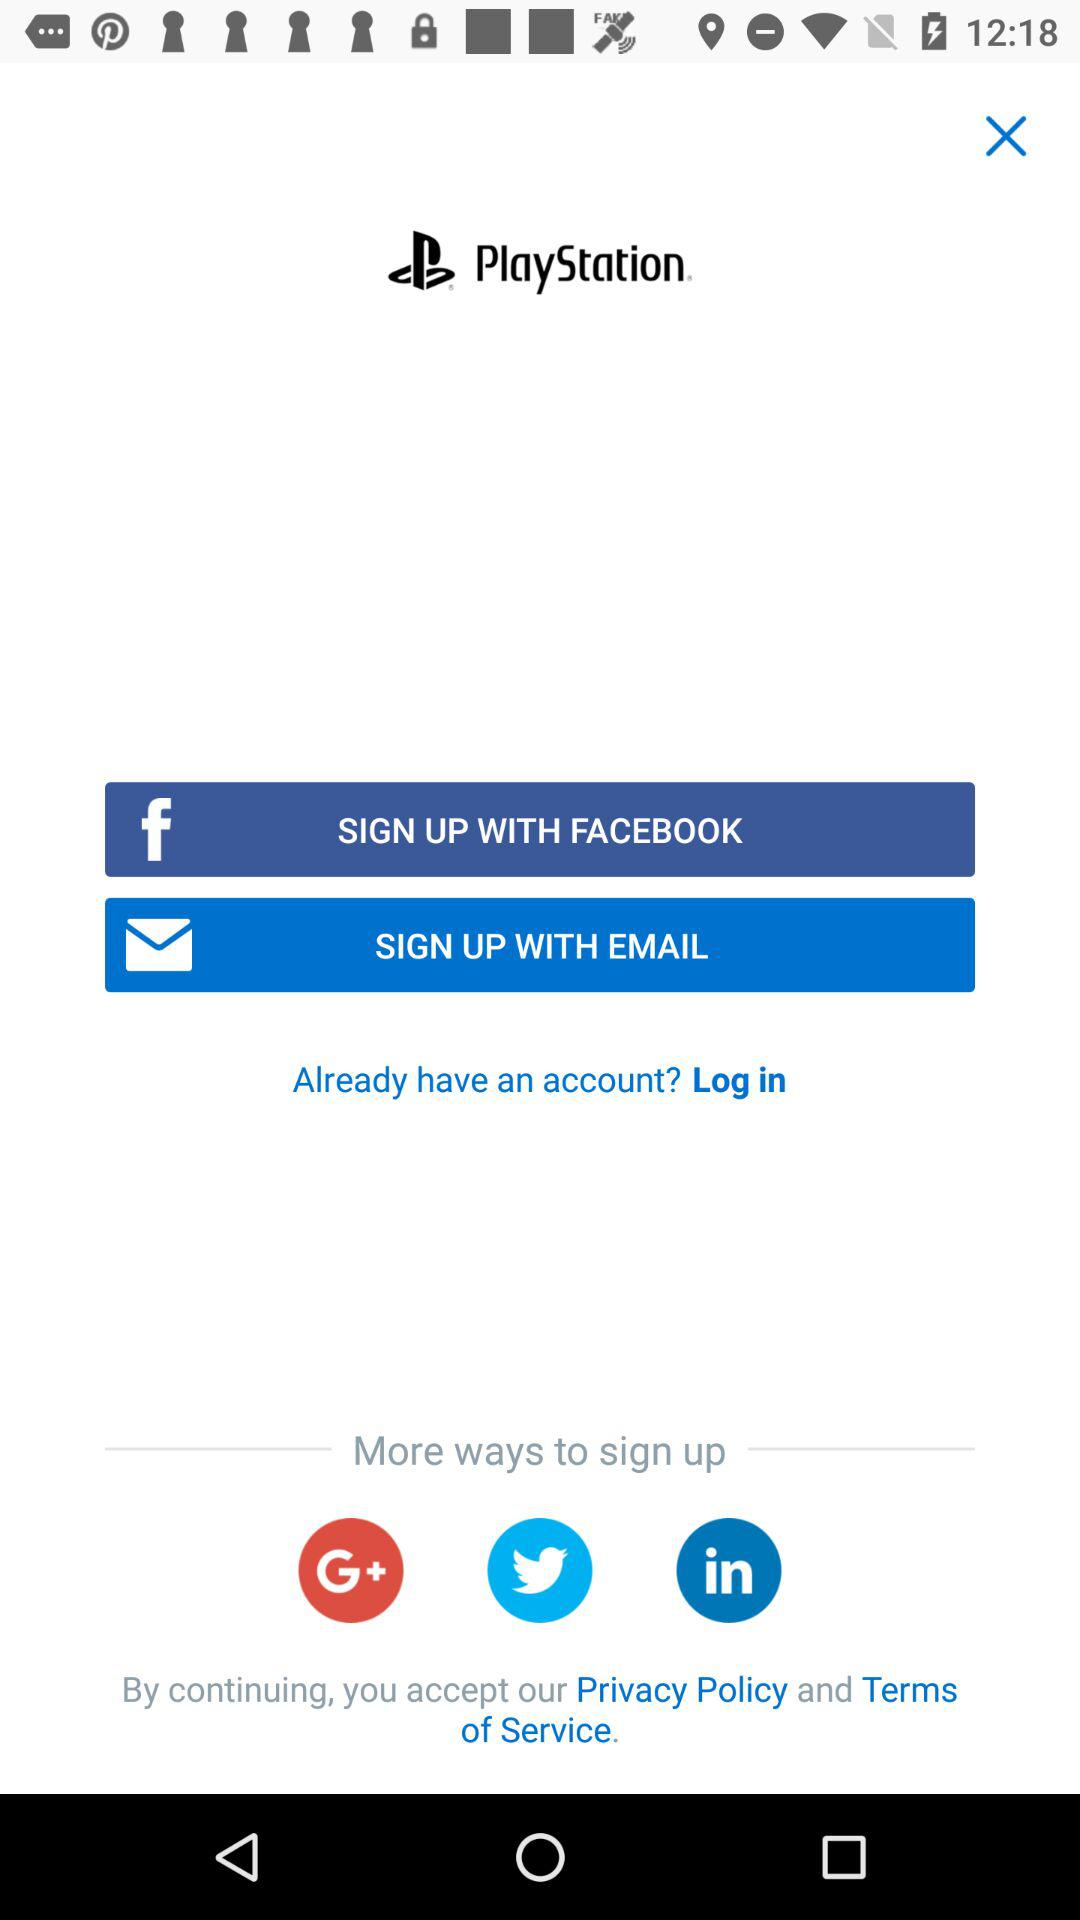What accounts can I use to sign up? The accounts are "FACEBOOK", "EMAIL", "GOOGLE+", "TWITTER", and "LINKEDIN". 